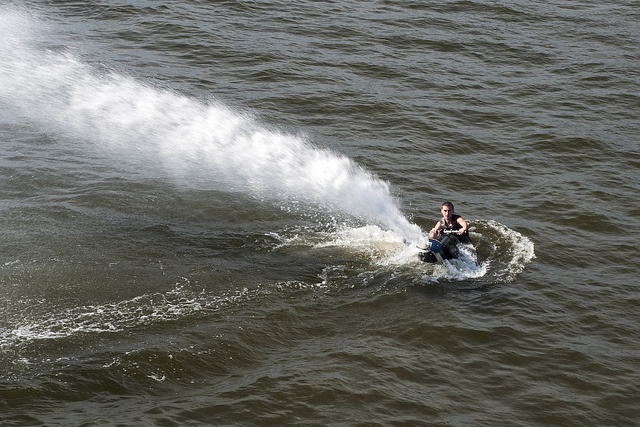Describe the objects in this image and their specific colors. I can see people in darkgray, black, lightgray, gray, and lightpink tones in this image. 